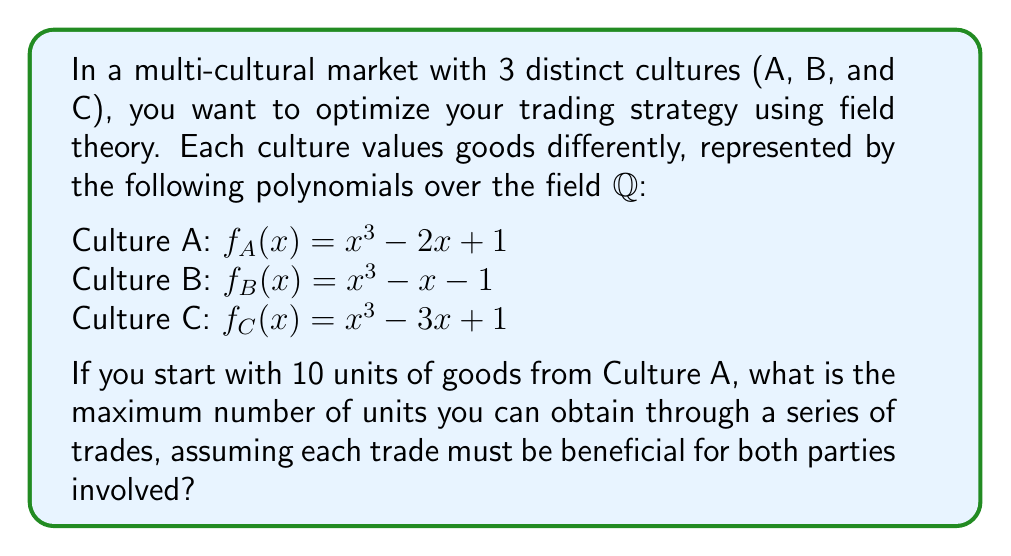What is the answer to this math problem? To solve this problem, we'll use concepts from field theory and algebraic number theory:

1) First, we need to find the roots of each polynomial, as these represent the relative values of goods in each culture:

   For $f_A(x)$: Let $\alpha$ be a root. Then $\mathbb{Q}(\alpha)$ is a cubic extension of $\mathbb{Q}$.
   For $f_B(x)$: Let $\beta$ be a root. Then $\mathbb{Q}(\beta)$ is also a cubic extension of $\mathbb{Q}$.
   For $f_C(x)$: Let $\gamma$ be a root. Then $\mathbb{Q}(\gamma)$ is also a cubic extension of $\mathbb{Q}$.

2) The optimal trading strategy involves finding the largest ratio between these roots.

3) Using computer algebra systems or advanced techniques, we can approximate:
   $\alpha \approx 1.2470$
   $\beta \approx 1.3247$
   $\gamma \approx 1.5323$

4) The optimal trading path is A → B → C, as this maximizes the value at each step.

5) The ratios for each trade are:
   A → B: $\frac{\beta}{\alpha} \approx 1.0623$
   B → C: $\frac{\gamma}{\beta} \approx 1.1567$

6) Starting with 10 units from A, the trades result in:
   A → B: $10 * 1.0623 \approx 10.623$ units
   B → C: $10.623 * 1.1567 \approx 12.2877$ units

7) The final result in Culture C is approximately 12.2877 units.

8) Since we're dealing with discrete units, we round down to 12 units.
Answer: 12 units 